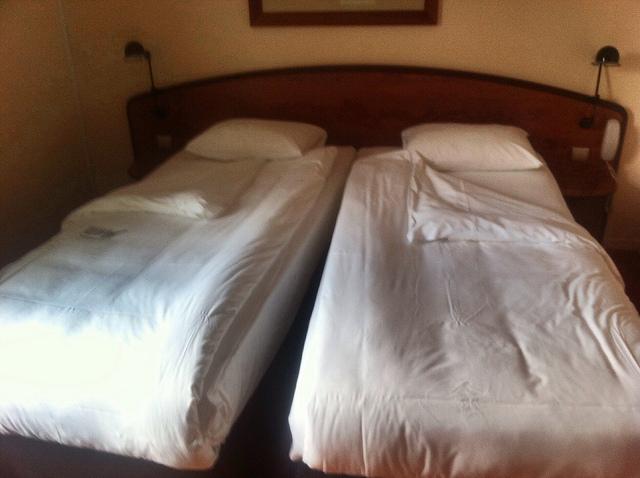Are the all pillows the same size?
Keep it brief. Yes. Are the sheets made of silk?
Keep it brief. No. If people sleep in these beds and roll over, will they fall into the crack?
Concise answer only. Yes. How many beds are there?
Short answer required. 2. Are the beds made?
Be succinct. Yes. 